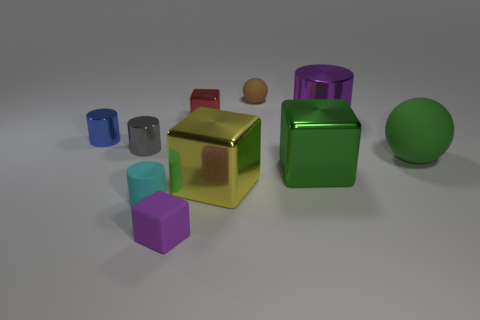Subtract all tiny gray shiny cylinders. How many cylinders are left? 3 Subtract all purple cylinders. How many cylinders are left? 3 Subtract 2 blocks. How many blocks are left? 2 Add 2 purple objects. How many purple objects are left? 4 Add 5 tiny brown rubber objects. How many tiny brown rubber objects exist? 6 Subtract 0 brown cylinders. How many objects are left? 10 Subtract all balls. How many objects are left? 8 Subtract all brown blocks. Subtract all blue balls. How many blocks are left? 4 Subtract all big yellow cubes. Subtract all purple matte objects. How many objects are left? 8 